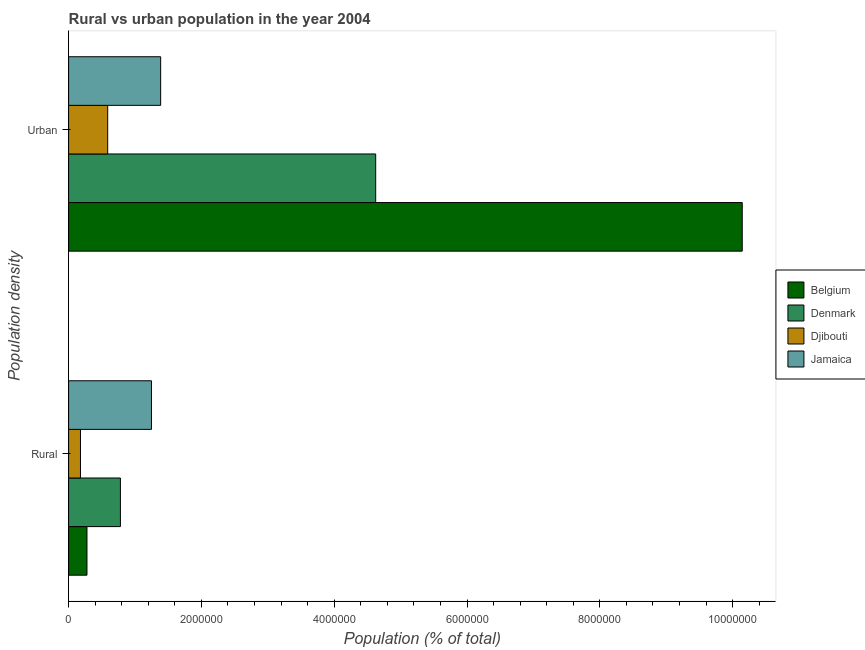What is the label of the 2nd group of bars from the top?
Your answer should be compact. Rural. What is the rural population density in Jamaica?
Your answer should be compact. 1.25e+06. Across all countries, what is the maximum urban population density?
Ensure brevity in your answer.  1.01e+07. Across all countries, what is the minimum urban population density?
Keep it short and to the point. 5.89e+05. In which country was the rural population density maximum?
Ensure brevity in your answer.  Jamaica. In which country was the rural population density minimum?
Your response must be concise. Djibouti. What is the total urban population density in the graph?
Offer a terse response. 1.67e+07. What is the difference between the rural population density in Jamaica and that in Djibouti?
Provide a short and direct response. 1.07e+06. What is the difference between the urban population density in Belgium and the rural population density in Djibouti?
Make the answer very short. 9.97e+06. What is the average rural population density per country?
Offer a very short reply. 6.21e+05. What is the difference between the rural population density and urban population density in Belgium?
Make the answer very short. -9.87e+06. In how many countries, is the rural population density greater than 9600000 %?
Ensure brevity in your answer.  0. What is the ratio of the rural population density in Denmark to that in Belgium?
Provide a succinct answer. 2.82. Is the urban population density in Denmark less than that in Djibouti?
Make the answer very short. No. What does the 1st bar from the top in Urban represents?
Offer a terse response. Jamaica. What does the 1st bar from the bottom in Urban represents?
Provide a short and direct response. Belgium. How many bars are there?
Provide a succinct answer. 8. How many countries are there in the graph?
Give a very brief answer. 4. What is the difference between two consecutive major ticks on the X-axis?
Make the answer very short. 2.00e+06. Are the values on the major ticks of X-axis written in scientific E-notation?
Make the answer very short. No. Does the graph contain any zero values?
Give a very brief answer. No. Where does the legend appear in the graph?
Provide a succinct answer. Center right. How are the legend labels stacked?
Offer a terse response. Vertical. What is the title of the graph?
Your answer should be very brief. Rural vs urban population in the year 2004. What is the label or title of the X-axis?
Your answer should be very brief. Population (% of total). What is the label or title of the Y-axis?
Your answer should be compact. Population density. What is the Population (% of total) of Belgium in Rural?
Your response must be concise. 2.77e+05. What is the Population (% of total) in Denmark in Rural?
Provide a succinct answer. 7.80e+05. What is the Population (% of total) in Djibouti in Rural?
Your response must be concise. 1.79e+05. What is the Population (% of total) in Jamaica in Rural?
Your answer should be compact. 1.25e+06. What is the Population (% of total) in Belgium in Urban?
Provide a succinct answer. 1.01e+07. What is the Population (% of total) of Denmark in Urban?
Offer a terse response. 4.62e+06. What is the Population (% of total) in Djibouti in Urban?
Ensure brevity in your answer.  5.89e+05. What is the Population (% of total) in Jamaica in Urban?
Provide a succinct answer. 1.39e+06. Across all Population density, what is the maximum Population (% of total) of Belgium?
Offer a terse response. 1.01e+07. Across all Population density, what is the maximum Population (% of total) of Denmark?
Your response must be concise. 4.62e+06. Across all Population density, what is the maximum Population (% of total) of Djibouti?
Offer a very short reply. 5.89e+05. Across all Population density, what is the maximum Population (% of total) in Jamaica?
Provide a succinct answer. 1.39e+06. Across all Population density, what is the minimum Population (% of total) of Belgium?
Give a very brief answer. 2.77e+05. Across all Population density, what is the minimum Population (% of total) in Denmark?
Your answer should be very brief. 7.80e+05. Across all Population density, what is the minimum Population (% of total) of Djibouti?
Give a very brief answer. 1.79e+05. Across all Population density, what is the minimum Population (% of total) of Jamaica?
Ensure brevity in your answer.  1.25e+06. What is the total Population (% of total) in Belgium in the graph?
Offer a terse response. 1.04e+07. What is the total Population (% of total) in Denmark in the graph?
Your response must be concise. 5.40e+06. What is the total Population (% of total) in Djibouti in the graph?
Provide a succinct answer. 7.68e+05. What is the total Population (% of total) in Jamaica in the graph?
Make the answer very short. 2.63e+06. What is the difference between the Population (% of total) in Belgium in Rural and that in Urban?
Offer a very short reply. -9.87e+06. What is the difference between the Population (% of total) in Denmark in Rural and that in Urban?
Offer a terse response. -3.84e+06. What is the difference between the Population (% of total) in Djibouti in Rural and that in Urban?
Make the answer very short. -4.10e+05. What is the difference between the Population (% of total) of Jamaica in Rural and that in Urban?
Make the answer very short. -1.38e+05. What is the difference between the Population (% of total) of Belgium in Rural and the Population (% of total) of Denmark in Urban?
Offer a terse response. -4.35e+06. What is the difference between the Population (% of total) of Belgium in Rural and the Population (% of total) of Djibouti in Urban?
Provide a succinct answer. -3.12e+05. What is the difference between the Population (% of total) in Belgium in Rural and the Population (% of total) in Jamaica in Urban?
Ensure brevity in your answer.  -1.11e+06. What is the difference between the Population (% of total) in Denmark in Rural and the Population (% of total) in Djibouti in Urban?
Keep it short and to the point. 1.91e+05. What is the difference between the Population (% of total) of Denmark in Rural and the Population (% of total) of Jamaica in Urban?
Keep it short and to the point. -6.06e+05. What is the difference between the Population (% of total) of Djibouti in Rural and the Population (% of total) of Jamaica in Urban?
Provide a short and direct response. -1.21e+06. What is the average Population (% of total) in Belgium per Population density?
Your response must be concise. 5.21e+06. What is the average Population (% of total) of Denmark per Population density?
Offer a terse response. 2.70e+06. What is the average Population (% of total) in Djibouti per Population density?
Offer a very short reply. 3.84e+05. What is the average Population (% of total) of Jamaica per Population density?
Give a very brief answer. 1.32e+06. What is the difference between the Population (% of total) in Belgium and Population (% of total) in Denmark in Rural?
Provide a succinct answer. -5.03e+05. What is the difference between the Population (% of total) in Belgium and Population (% of total) in Djibouti in Rural?
Your answer should be compact. 9.79e+04. What is the difference between the Population (% of total) of Belgium and Population (% of total) of Jamaica in Rural?
Provide a succinct answer. -9.71e+05. What is the difference between the Population (% of total) in Denmark and Population (% of total) in Djibouti in Rural?
Make the answer very short. 6.01e+05. What is the difference between the Population (% of total) in Denmark and Population (% of total) in Jamaica in Rural?
Offer a very short reply. -4.68e+05. What is the difference between the Population (% of total) of Djibouti and Population (% of total) of Jamaica in Rural?
Make the answer very short. -1.07e+06. What is the difference between the Population (% of total) in Belgium and Population (% of total) in Denmark in Urban?
Keep it short and to the point. 5.52e+06. What is the difference between the Population (% of total) of Belgium and Population (% of total) of Djibouti in Urban?
Give a very brief answer. 9.56e+06. What is the difference between the Population (% of total) in Belgium and Population (% of total) in Jamaica in Urban?
Give a very brief answer. 8.76e+06. What is the difference between the Population (% of total) of Denmark and Population (% of total) of Djibouti in Urban?
Make the answer very short. 4.04e+06. What is the difference between the Population (% of total) of Denmark and Population (% of total) of Jamaica in Urban?
Offer a very short reply. 3.24e+06. What is the difference between the Population (% of total) of Djibouti and Population (% of total) of Jamaica in Urban?
Keep it short and to the point. -7.97e+05. What is the ratio of the Population (% of total) of Belgium in Rural to that in Urban?
Ensure brevity in your answer.  0.03. What is the ratio of the Population (% of total) of Denmark in Rural to that in Urban?
Your answer should be very brief. 0.17. What is the ratio of the Population (% of total) of Djibouti in Rural to that in Urban?
Offer a terse response. 0.3. What is the ratio of the Population (% of total) in Jamaica in Rural to that in Urban?
Provide a short and direct response. 0.9. What is the difference between the highest and the second highest Population (% of total) of Belgium?
Offer a terse response. 9.87e+06. What is the difference between the highest and the second highest Population (% of total) of Denmark?
Your response must be concise. 3.84e+06. What is the difference between the highest and the second highest Population (% of total) in Djibouti?
Keep it short and to the point. 4.10e+05. What is the difference between the highest and the second highest Population (% of total) of Jamaica?
Your answer should be compact. 1.38e+05. What is the difference between the highest and the lowest Population (% of total) in Belgium?
Make the answer very short. 9.87e+06. What is the difference between the highest and the lowest Population (% of total) of Denmark?
Make the answer very short. 3.84e+06. What is the difference between the highest and the lowest Population (% of total) of Djibouti?
Provide a short and direct response. 4.10e+05. What is the difference between the highest and the lowest Population (% of total) in Jamaica?
Keep it short and to the point. 1.38e+05. 